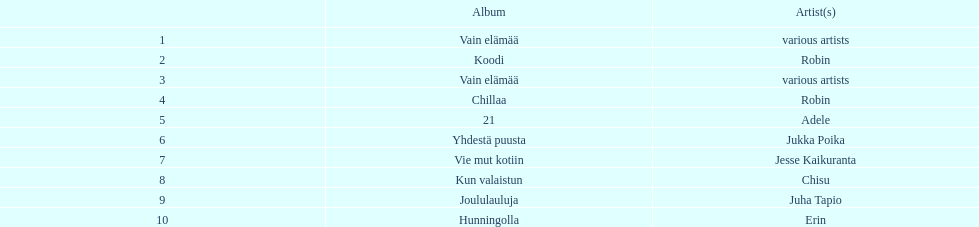Tell me an album that had the same artist as chillaa. Koodi. 